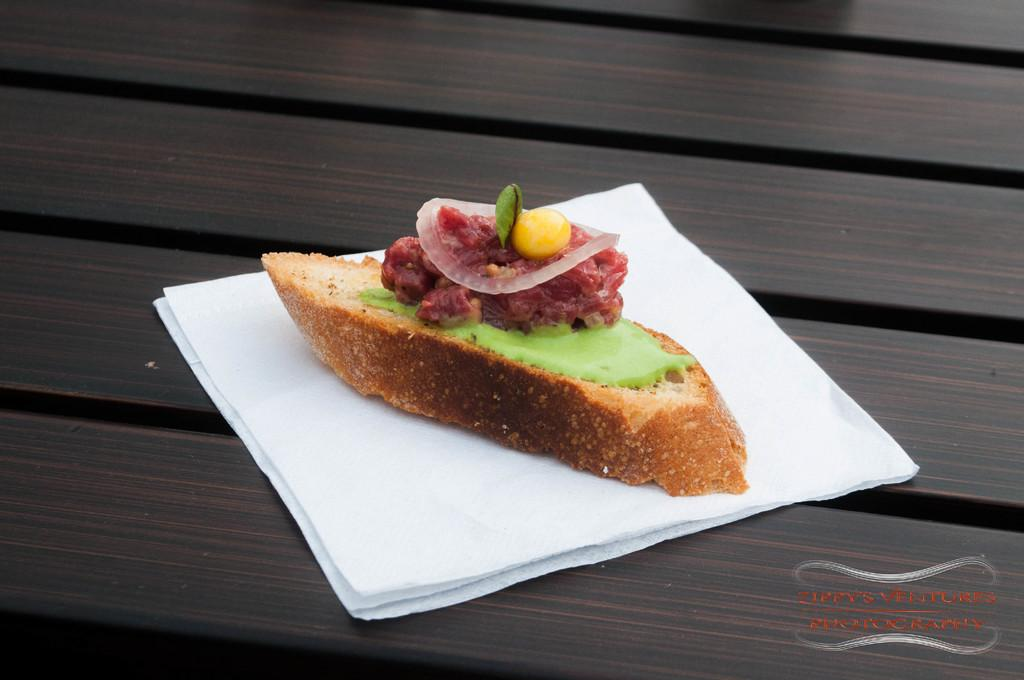What is present on the white tissue in the image? There is food on the white tissue in the image. What is the color of the tissue? The tissue is white. On what surface is the tissue placed? The tissue is on a brown and black table. What colors can be seen in the food? The food has colors including brown, green, red, and yellow. Can you see any toes in the image? There are no toes visible in the image. What type of match is being played in the image? There is no match being played in the image. 